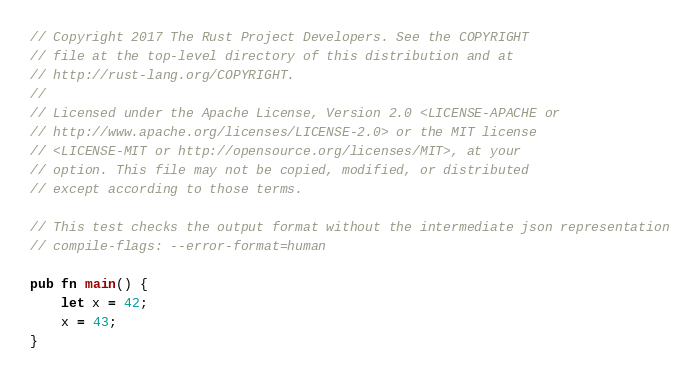Convert code to text. <code><loc_0><loc_0><loc_500><loc_500><_Rust_>// Copyright 2017 The Rust Project Developers. See the COPYRIGHT
// file at the top-level directory of this distribution and at
// http://rust-lang.org/COPYRIGHT.
//
// Licensed under the Apache License, Version 2.0 <LICENSE-APACHE or
// http://www.apache.org/licenses/LICENSE-2.0> or the MIT license
// <LICENSE-MIT or http://opensource.org/licenses/MIT>, at your
// option. This file may not be copied, modified, or distributed
// except according to those terms.

// This test checks the output format without the intermediate json representation
// compile-flags: --error-format=human

pub fn main() {
    let x = 42;
    x = 43;
}
</code> 